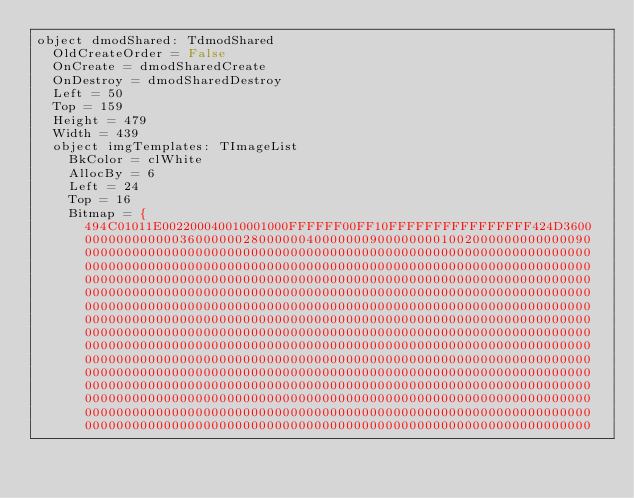Convert code to text. <code><loc_0><loc_0><loc_500><loc_500><_Pascal_>object dmodShared: TdmodShared
  OldCreateOrder = False
  OnCreate = dmodSharedCreate
  OnDestroy = dmodSharedDestroy
  Left = 50
  Top = 159
  Height = 479
  Width = 439
  object imgTemplates: TImageList
    BkColor = clWhite
    AllocBy = 6
    Left = 24
    Top = 16
    Bitmap = {
      494C01011E002200040010001000FFFFFF00FF10FFFFFFFFFFFFFFFF424D3600
      0000000000003600000028000000400000009000000001002000000000000090
      0000000000000000000000000000000000000000000000000000000000000000
      0000000000000000000000000000000000000000000000000000000000000000
      0000000000000000000000000000000000000000000000000000000000000000
      0000000000000000000000000000000000000000000000000000000000000000
      0000000000000000000000000000000000000000000000000000000000000000
      0000000000000000000000000000000000000000000000000000000000000000
      0000000000000000000000000000000000000000000000000000000000000000
      0000000000000000000000000000000000000000000000000000000000000000
      0000000000000000000000000000000000000000000000000000000000000000
      0000000000000000000000000000000000000000000000000000000000000000
      0000000000000000000000000000000000000000000000000000000000000000
      0000000000000000000000000000000000000000000000000000000000000000
      0000000000000000000000000000000000000000000000000000000000000000
      0000000000000000000000000000000000000000000000000000000000000000</code> 